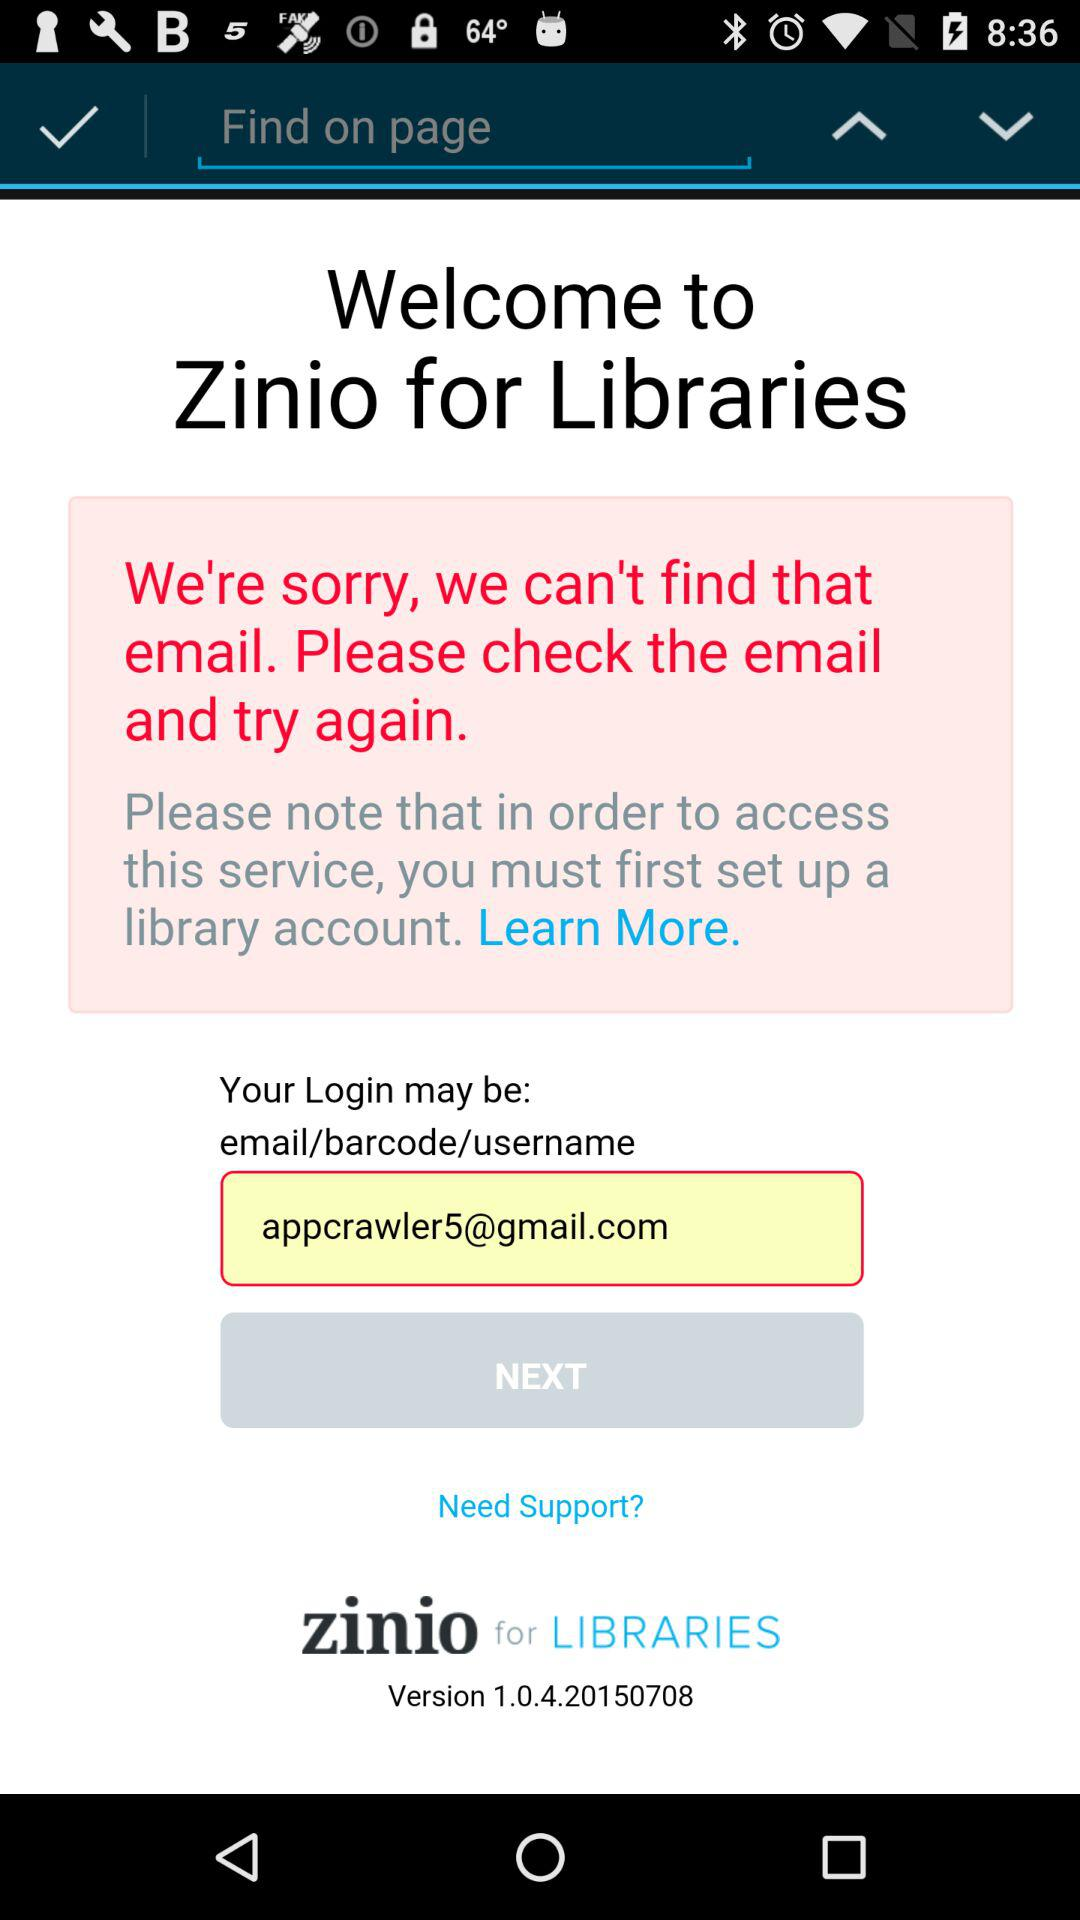What is the version? The version is 1.0.4.20150708. 